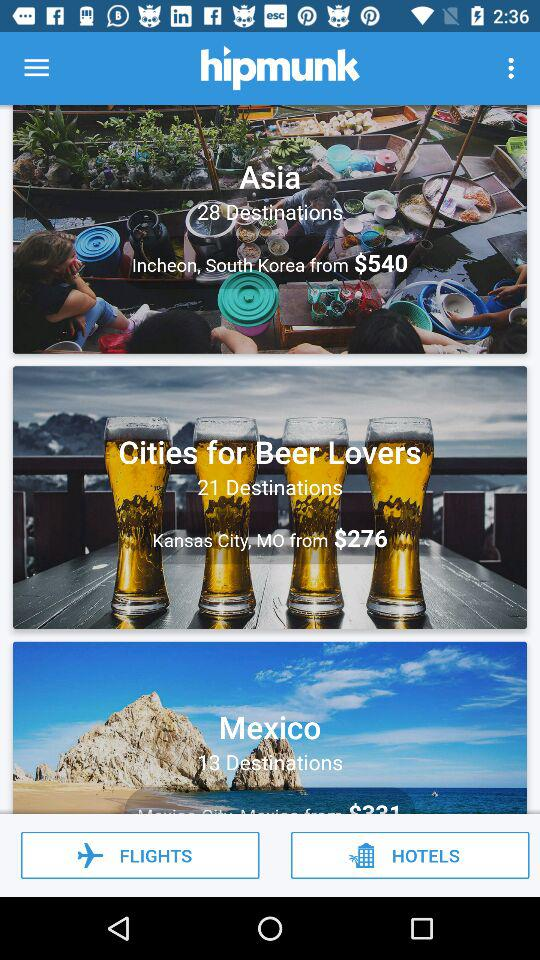How many destinations are there in Asia? There are 28 destinations in Asia. 